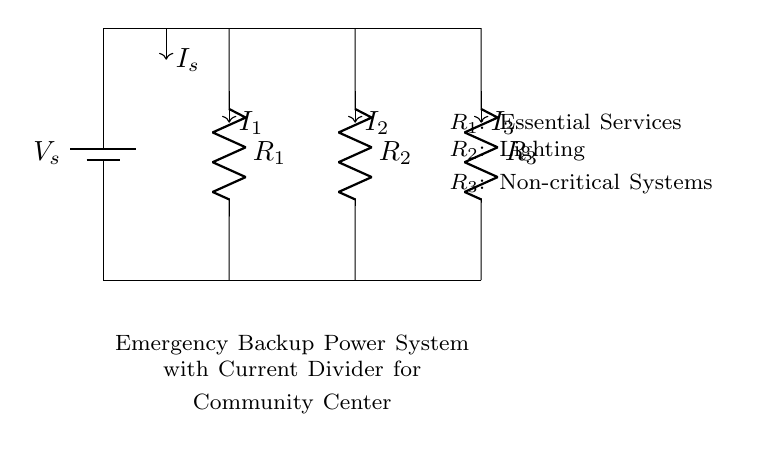What is the total number of resistors in this circuit? There are three resistors in the circuit, labeled as R1, R2, and R3, which are in parallel configuration.
Answer: 3 What does R1 serve in this circuit? R1 is designated for essential services, indicating it plays a critical role in the backup power system for the community center.
Answer: Essential Services What is the current flowing through R2? The current through R2, represented as I2, is a portion of the total current I_s that is divided among the resistors. The exact value isn't given, but it is specifically for lighting.
Answer: I2 What type of circuit configuration is used in this system? The circuit primarily employs a parallel configuration, as the voltage across each resistor is the same while the current divides amongst them.
Answer: Parallel What function does the battery serve in this circuit? The battery, labeled as Vs, provides the necessary voltage to power the entire circuit, ensuring the resistors receive energy during an emergency.
Answer: Provides voltage Which resistors are considered non-critical systems? R3 is the resistor designated for non-critical systems in the backup power layout, meaning it can be powered down without affecting essential operations.
Answer: Non-critical Systems 